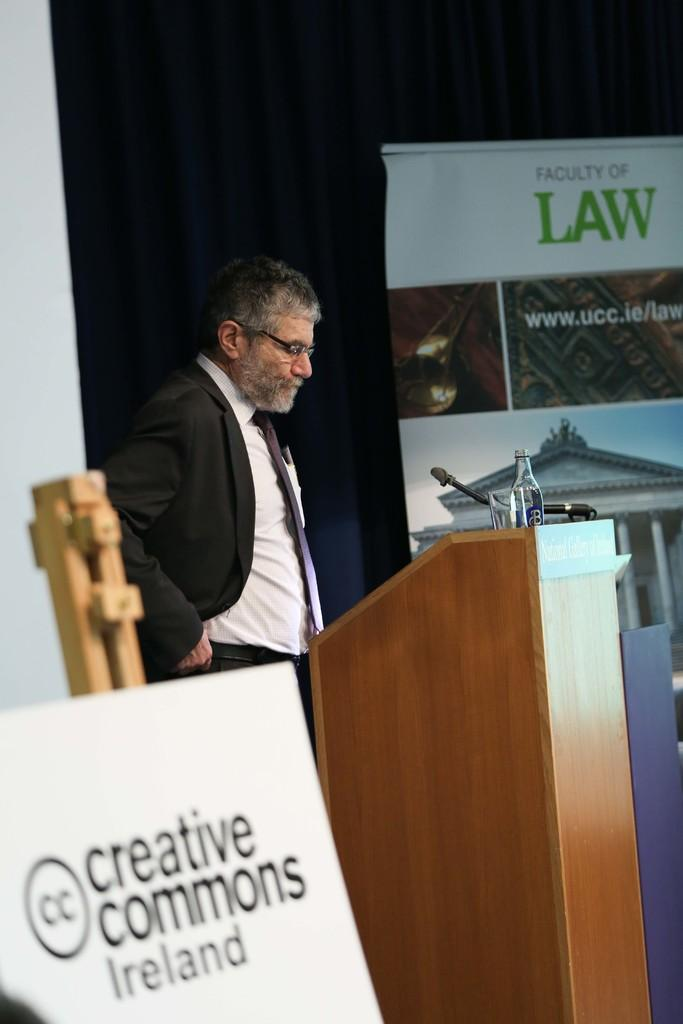What is the main object in the image? There is a name board in the image. Who or what is associated with the name board? There is a person in the image. What is the person standing in front of? The person is standing in front of a podium. What is on the podium? A microphone (mic) and a bottle are present on the podium. What can be seen in the background of the image? There is a curtain and a poster in the background of the image. What type of locket is the person wearing in the image? There is no locket visible on the person in the image. How does the tramp contribute to the scene in the image? There is no tramp present in the image; it features a person, a name board, a podium, a microphone, a bottle, a curtain, and a poster. 